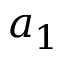Convert formula to latex. <formula><loc_0><loc_0><loc_500><loc_500>a _ { 1 }</formula> 